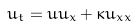Convert formula to latex. <formula><loc_0><loc_0><loc_500><loc_500>u _ { t } = u u _ { x } + \kappa u _ { x x }</formula> 